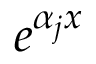<formula> <loc_0><loc_0><loc_500><loc_500>e ^ { \alpha _ { j } x }</formula> 